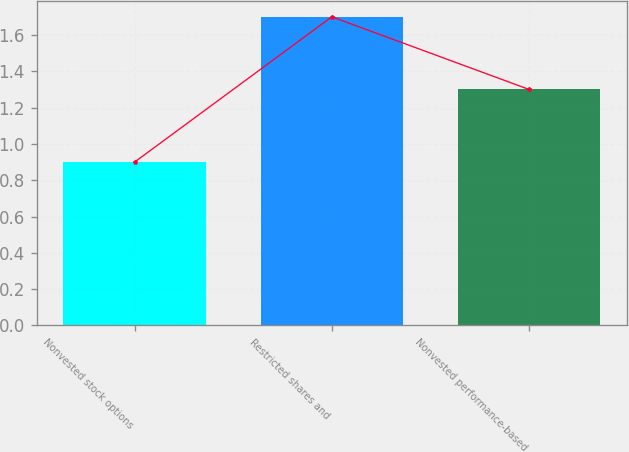Convert chart. <chart><loc_0><loc_0><loc_500><loc_500><bar_chart><fcel>Nonvested stock options<fcel>Restricted shares and<fcel>Nonvested performance-based<nl><fcel>0.9<fcel>1.7<fcel>1.3<nl></chart> 